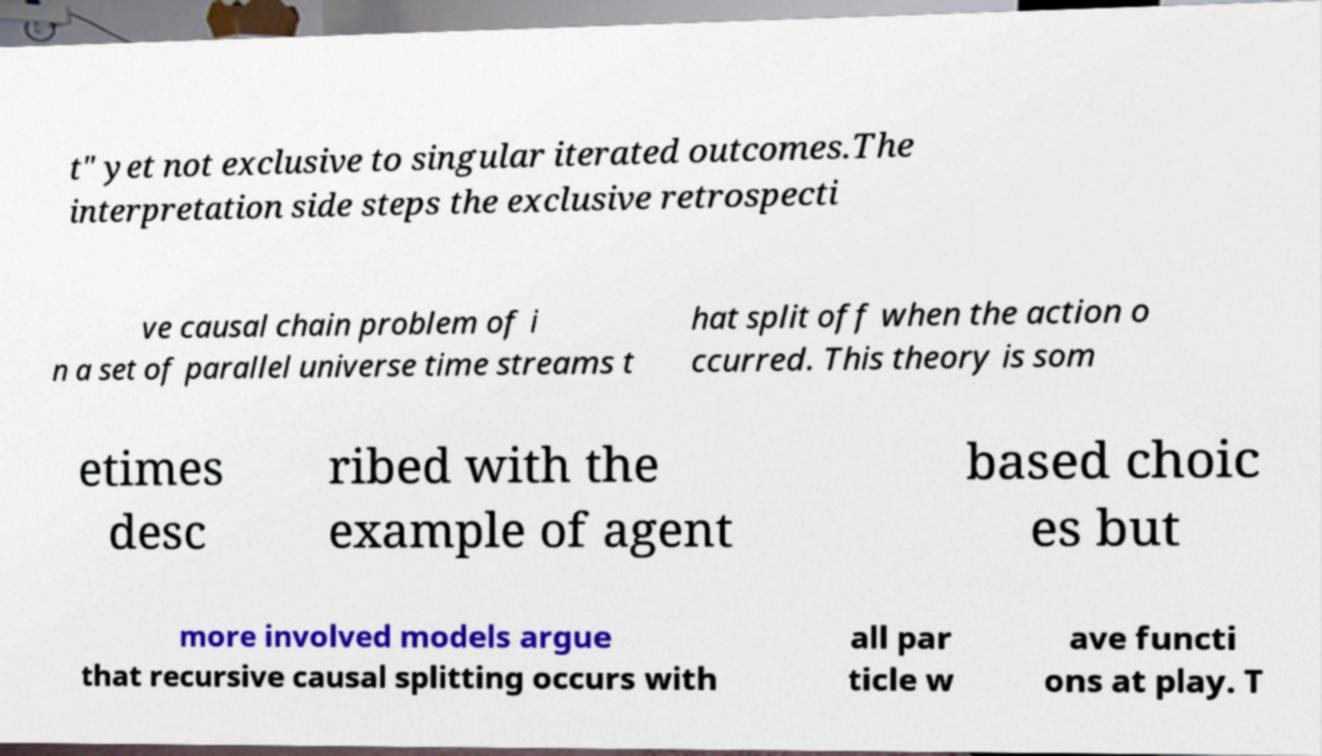What messages or text are displayed in this image? I need them in a readable, typed format. t" yet not exclusive to singular iterated outcomes.The interpretation side steps the exclusive retrospecti ve causal chain problem of i n a set of parallel universe time streams t hat split off when the action o ccurred. This theory is som etimes desc ribed with the example of agent based choic es but more involved models argue that recursive causal splitting occurs with all par ticle w ave functi ons at play. T 